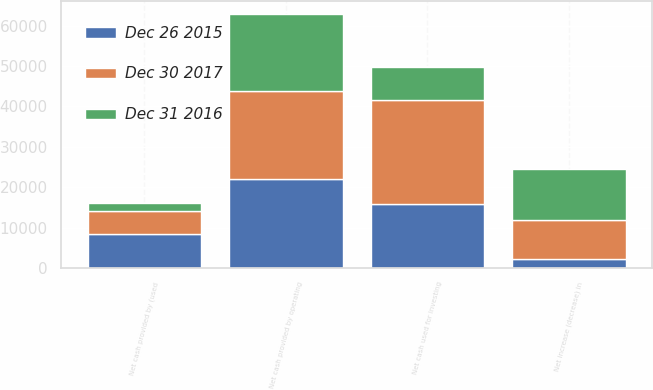Convert chart. <chart><loc_0><loc_0><loc_500><loc_500><stacked_bar_chart><ecel><fcel>Net cash provided by operating<fcel>Net cash used for investing<fcel>Net cash provided by (used<fcel>Net increase (decrease) in<nl><fcel>Dec 26 2015<fcel>22110<fcel>15762<fcel>8475<fcel>2127<nl><fcel>Dec 30 2017<fcel>21808<fcel>25817<fcel>5739<fcel>9748<nl><fcel>Dec 31 2016<fcel>19018<fcel>8183<fcel>1912<fcel>12747<nl></chart> 